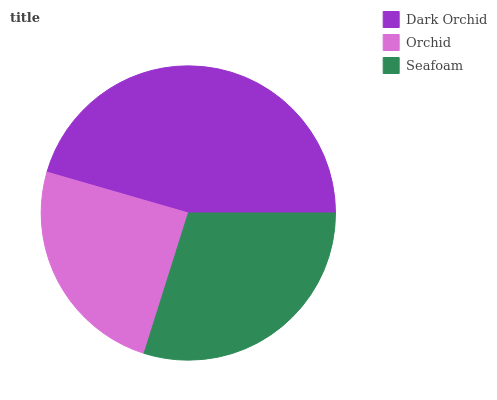Is Orchid the minimum?
Answer yes or no. Yes. Is Dark Orchid the maximum?
Answer yes or no. Yes. Is Seafoam the minimum?
Answer yes or no. No. Is Seafoam the maximum?
Answer yes or no. No. Is Seafoam greater than Orchid?
Answer yes or no. Yes. Is Orchid less than Seafoam?
Answer yes or no. Yes. Is Orchid greater than Seafoam?
Answer yes or no. No. Is Seafoam less than Orchid?
Answer yes or no. No. Is Seafoam the high median?
Answer yes or no. Yes. Is Seafoam the low median?
Answer yes or no. Yes. Is Orchid the high median?
Answer yes or no. No. Is Dark Orchid the low median?
Answer yes or no. No. 